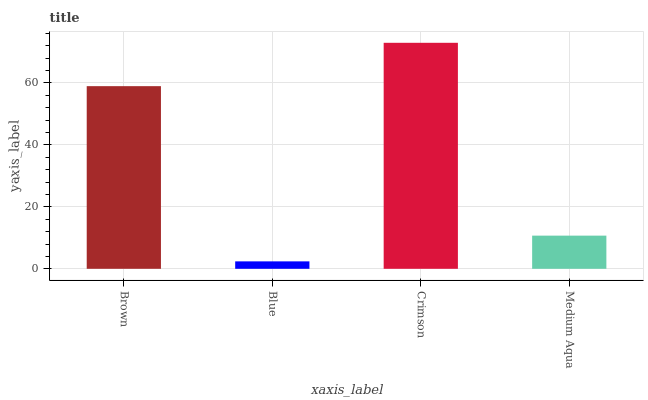Is Blue the minimum?
Answer yes or no. Yes. Is Crimson the maximum?
Answer yes or no. Yes. Is Crimson the minimum?
Answer yes or no. No. Is Blue the maximum?
Answer yes or no. No. Is Crimson greater than Blue?
Answer yes or no. Yes. Is Blue less than Crimson?
Answer yes or no. Yes. Is Blue greater than Crimson?
Answer yes or no. No. Is Crimson less than Blue?
Answer yes or no. No. Is Brown the high median?
Answer yes or no. Yes. Is Medium Aqua the low median?
Answer yes or no. Yes. Is Medium Aqua the high median?
Answer yes or no. No. Is Brown the low median?
Answer yes or no. No. 